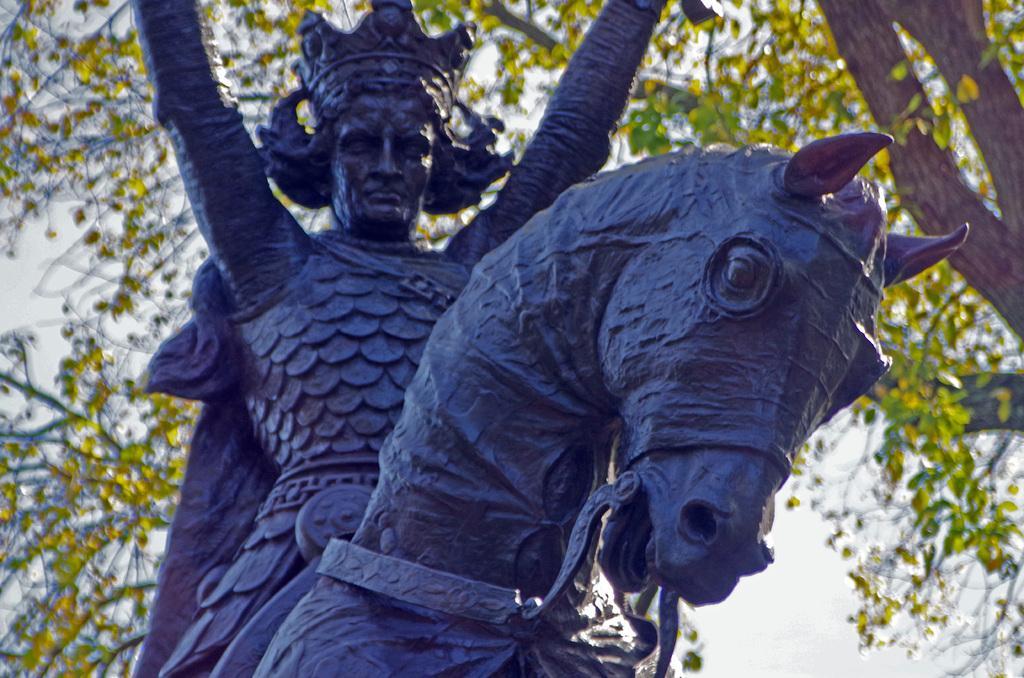Please provide a concise description of this image. In this picture there is a statue of a person sitting on the horse. At the back there are trees. At the top there is sky. 